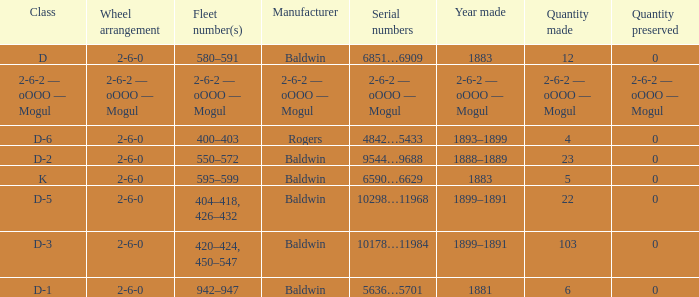What is the wheel arrangement when the year made is 1881? 2-6-0. 